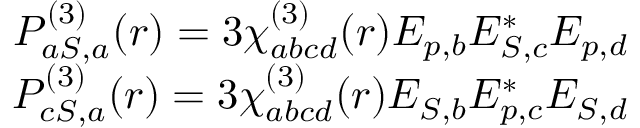<formula> <loc_0><loc_0><loc_500><loc_500>\begin{array} { r } { P _ { a S , a } ^ { ( 3 ) } ( r ) = 3 \chi _ { a b c d } ^ { ( 3 ) } ( r ) E _ { p , b } E _ { S , c } ^ { * } E _ { p , d } } \\ { P _ { c S , a } ^ { ( 3 ) } ( r ) = 3 \chi _ { a b c d } ^ { ( 3 ) } ( r ) E _ { S , b } E _ { p , c } ^ { * } E _ { S , d } } \end{array}</formula> 